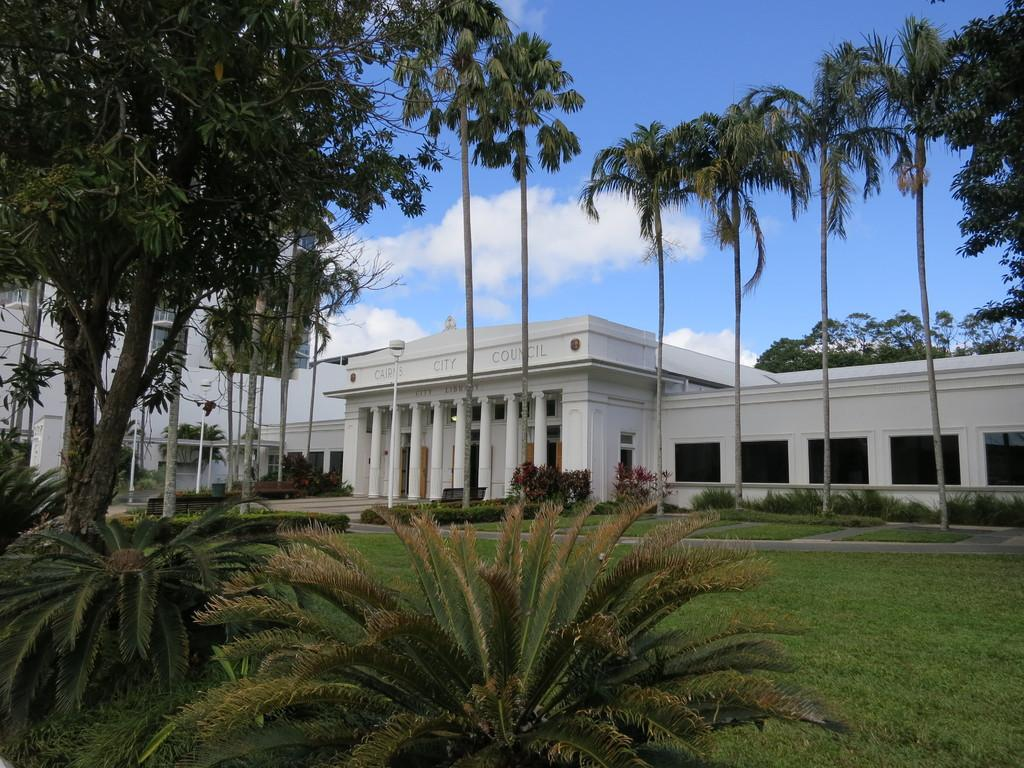What type of structures can be seen in the image? There are buildings in the image. What type of vegetation is present in the image? There is grass, plants, and trees in the image. What type of seating is available in the image? There is a bench in the image. What is the condition of the sky in the image? The sky is cloudy in the image. What month is it in the image? The month cannot be determined from the image, as there is no information about the time of year. Can you see any wires or tanks in the image? There are no wires or tanks present in the image. 